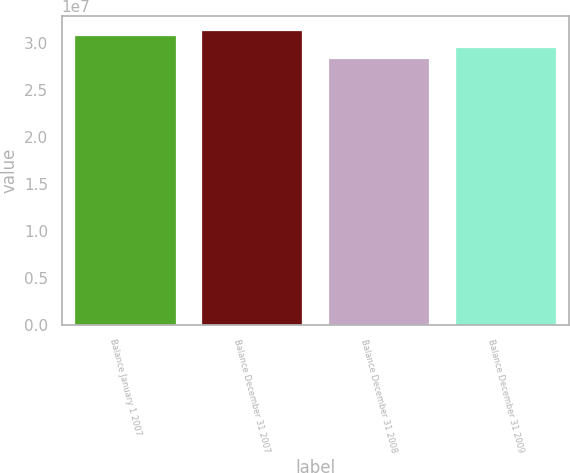Convert chart to OTSL. <chart><loc_0><loc_0><loc_500><loc_500><bar_chart><fcel>Balance January 1 2007<fcel>Balance December 31 2007<fcel>Balance December 31 2008<fcel>Balance December 31 2009<nl><fcel>3.0903e+07<fcel>3.13628e+07<fcel>2.84608e+07<fcel>2.95633e+07<nl></chart> 